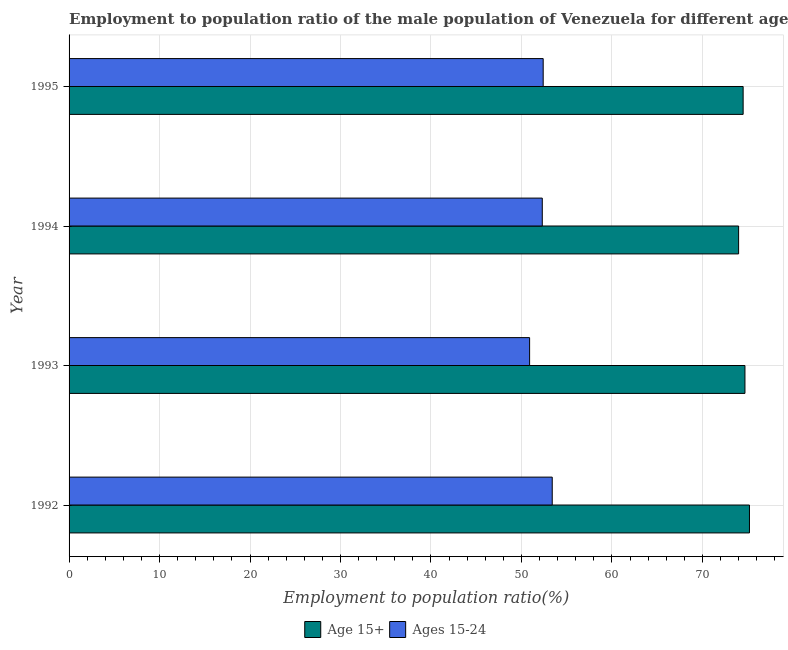Are the number of bars on each tick of the Y-axis equal?
Make the answer very short. Yes. How many bars are there on the 3rd tick from the top?
Offer a terse response. 2. In how many cases, is the number of bars for a given year not equal to the number of legend labels?
Offer a very short reply. 0. What is the employment to population ratio(age 15-24) in 1993?
Make the answer very short. 50.9. Across all years, what is the maximum employment to population ratio(age 15+)?
Make the answer very short. 75.2. In which year was the employment to population ratio(age 15-24) maximum?
Make the answer very short. 1992. What is the total employment to population ratio(age 15-24) in the graph?
Provide a short and direct response. 209. What is the difference between the employment to population ratio(age 15-24) in 1992 and that in 1994?
Keep it short and to the point. 1.1. What is the difference between the employment to population ratio(age 15+) in 1994 and the employment to population ratio(age 15-24) in 1992?
Ensure brevity in your answer.  20.6. What is the average employment to population ratio(age 15+) per year?
Your answer should be compact. 74.6. In the year 1995, what is the difference between the employment to population ratio(age 15-24) and employment to population ratio(age 15+)?
Your response must be concise. -22.1. What is the ratio of the employment to population ratio(age 15+) in 1992 to that in 1995?
Your answer should be compact. 1.01. Is the employment to population ratio(age 15+) in 1993 less than that in 1994?
Provide a succinct answer. No. What is the difference between the highest and the lowest employment to population ratio(age 15+)?
Provide a short and direct response. 1.2. What does the 2nd bar from the top in 1992 represents?
Your response must be concise. Age 15+. What does the 2nd bar from the bottom in 1993 represents?
Provide a short and direct response. Ages 15-24. Are all the bars in the graph horizontal?
Give a very brief answer. Yes. Are the values on the major ticks of X-axis written in scientific E-notation?
Ensure brevity in your answer.  No. Does the graph contain grids?
Your response must be concise. Yes. Where does the legend appear in the graph?
Ensure brevity in your answer.  Bottom center. How many legend labels are there?
Make the answer very short. 2. How are the legend labels stacked?
Your answer should be compact. Horizontal. What is the title of the graph?
Your answer should be very brief. Employment to population ratio of the male population of Venezuela for different age-groups. Does "Electricity and heat production" appear as one of the legend labels in the graph?
Offer a very short reply. No. What is the Employment to population ratio(%) in Age 15+ in 1992?
Your answer should be compact. 75.2. What is the Employment to population ratio(%) of Ages 15-24 in 1992?
Offer a terse response. 53.4. What is the Employment to population ratio(%) of Age 15+ in 1993?
Keep it short and to the point. 74.7. What is the Employment to population ratio(%) in Ages 15-24 in 1993?
Ensure brevity in your answer.  50.9. What is the Employment to population ratio(%) of Ages 15-24 in 1994?
Offer a very short reply. 52.3. What is the Employment to population ratio(%) of Age 15+ in 1995?
Provide a succinct answer. 74.5. What is the Employment to population ratio(%) of Ages 15-24 in 1995?
Provide a short and direct response. 52.4. Across all years, what is the maximum Employment to population ratio(%) in Age 15+?
Your answer should be compact. 75.2. Across all years, what is the maximum Employment to population ratio(%) of Ages 15-24?
Make the answer very short. 53.4. Across all years, what is the minimum Employment to population ratio(%) of Age 15+?
Provide a succinct answer. 74. Across all years, what is the minimum Employment to population ratio(%) of Ages 15-24?
Offer a terse response. 50.9. What is the total Employment to population ratio(%) in Age 15+ in the graph?
Your answer should be very brief. 298.4. What is the total Employment to population ratio(%) in Ages 15-24 in the graph?
Your answer should be compact. 209. What is the difference between the Employment to population ratio(%) in Age 15+ in 1992 and that in 1994?
Make the answer very short. 1.2. What is the difference between the Employment to population ratio(%) of Ages 15-24 in 1992 and that in 1994?
Offer a very short reply. 1.1. What is the difference between the Employment to population ratio(%) of Ages 15-24 in 1993 and that in 1994?
Offer a terse response. -1.4. What is the difference between the Employment to population ratio(%) in Age 15+ in 1994 and that in 1995?
Your answer should be very brief. -0.5. What is the difference between the Employment to population ratio(%) of Ages 15-24 in 1994 and that in 1995?
Provide a succinct answer. -0.1. What is the difference between the Employment to population ratio(%) of Age 15+ in 1992 and the Employment to population ratio(%) of Ages 15-24 in 1993?
Offer a terse response. 24.3. What is the difference between the Employment to population ratio(%) in Age 15+ in 1992 and the Employment to population ratio(%) in Ages 15-24 in 1994?
Give a very brief answer. 22.9. What is the difference between the Employment to population ratio(%) of Age 15+ in 1992 and the Employment to population ratio(%) of Ages 15-24 in 1995?
Offer a terse response. 22.8. What is the difference between the Employment to population ratio(%) in Age 15+ in 1993 and the Employment to population ratio(%) in Ages 15-24 in 1994?
Ensure brevity in your answer.  22.4. What is the difference between the Employment to population ratio(%) in Age 15+ in 1993 and the Employment to population ratio(%) in Ages 15-24 in 1995?
Make the answer very short. 22.3. What is the difference between the Employment to population ratio(%) of Age 15+ in 1994 and the Employment to population ratio(%) of Ages 15-24 in 1995?
Your answer should be very brief. 21.6. What is the average Employment to population ratio(%) of Age 15+ per year?
Ensure brevity in your answer.  74.6. What is the average Employment to population ratio(%) in Ages 15-24 per year?
Offer a very short reply. 52.25. In the year 1992, what is the difference between the Employment to population ratio(%) of Age 15+ and Employment to population ratio(%) of Ages 15-24?
Your answer should be very brief. 21.8. In the year 1993, what is the difference between the Employment to population ratio(%) in Age 15+ and Employment to population ratio(%) in Ages 15-24?
Provide a succinct answer. 23.8. In the year 1994, what is the difference between the Employment to population ratio(%) in Age 15+ and Employment to population ratio(%) in Ages 15-24?
Offer a terse response. 21.7. In the year 1995, what is the difference between the Employment to population ratio(%) in Age 15+ and Employment to population ratio(%) in Ages 15-24?
Provide a short and direct response. 22.1. What is the ratio of the Employment to population ratio(%) in Age 15+ in 1992 to that in 1993?
Your response must be concise. 1.01. What is the ratio of the Employment to population ratio(%) of Ages 15-24 in 1992 to that in 1993?
Provide a short and direct response. 1.05. What is the ratio of the Employment to population ratio(%) of Age 15+ in 1992 to that in 1994?
Your answer should be very brief. 1.02. What is the ratio of the Employment to population ratio(%) of Ages 15-24 in 1992 to that in 1994?
Provide a short and direct response. 1.02. What is the ratio of the Employment to population ratio(%) of Age 15+ in 1992 to that in 1995?
Offer a very short reply. 1.01. What is the ratio of the Employment to population ratio(%) in Ages 15-24 in 1992 to that in 1995?
Ensure brevity in your answer.  1.02. What is the ratio of the Employment to population ratio(%) in Age 15+ in 1993 to that in 1994?
Offer a terse response. 1.01. What is the ratio of the Employment to population ratio(%) of Ages 15-24 in 1993 to that in 1994?
Offer a terse response. 0.97. What is the ratio of the Employment to population ratio(%) in Age 15+ in 1993 to that in 1995?
Provide a short and direct response. 1. What is the ratio of the Employment to population ratio(%) of Ages 15-24 in 1993 to that in 1995?
Provide a succinct answer. 0.97. What is the ratio of the Employment to population ratio(%) of Age 15+ in 1994 to that in 1995?
Provide a succinct answer. 0.99. What is the ratio of the Employment to population ratio(%) in Ages 15-24 in 1994 to that in 1995?
Provide a succinct answer. 1. What is the difference between the highest and the second highest Employment to population ratio(%) in Age 15+?
Ensure brevity in your answer.  0.5. What is the difference between the highest and the second highest Employment to population ratio(%) in Ages 15-24?
Your answer should be very brief. 1. 